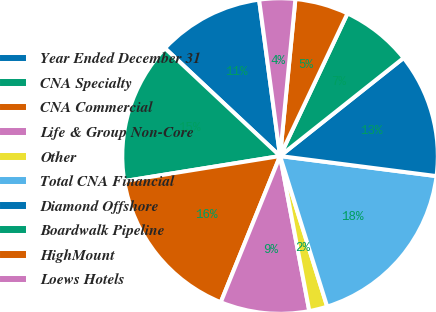Convert chart to OTSL. <chart><loc_0><loc_0><loc_500><loc_500><pie_chart><fcel>Year Ended December 31<fcel>CNA Specialty<fcel>CNA Commercial<fcel>Life & Group Non-Core<fcel>Other<fcel>Total CNA Financial<fcel>Diamond Offshore<fcel>Boardwalk Pipeline<fcel>HighMount<fcel>Loews Hotels<nl><fcel>10.9%<fcel>14.52%<fcel>16.33%<fcel>9.1%<fcel>1.86%<fcel>18.14%<fcel>12.71%<fcel>7.29%<fcel>5.48%<fcel>3.67%<nl></chart> 